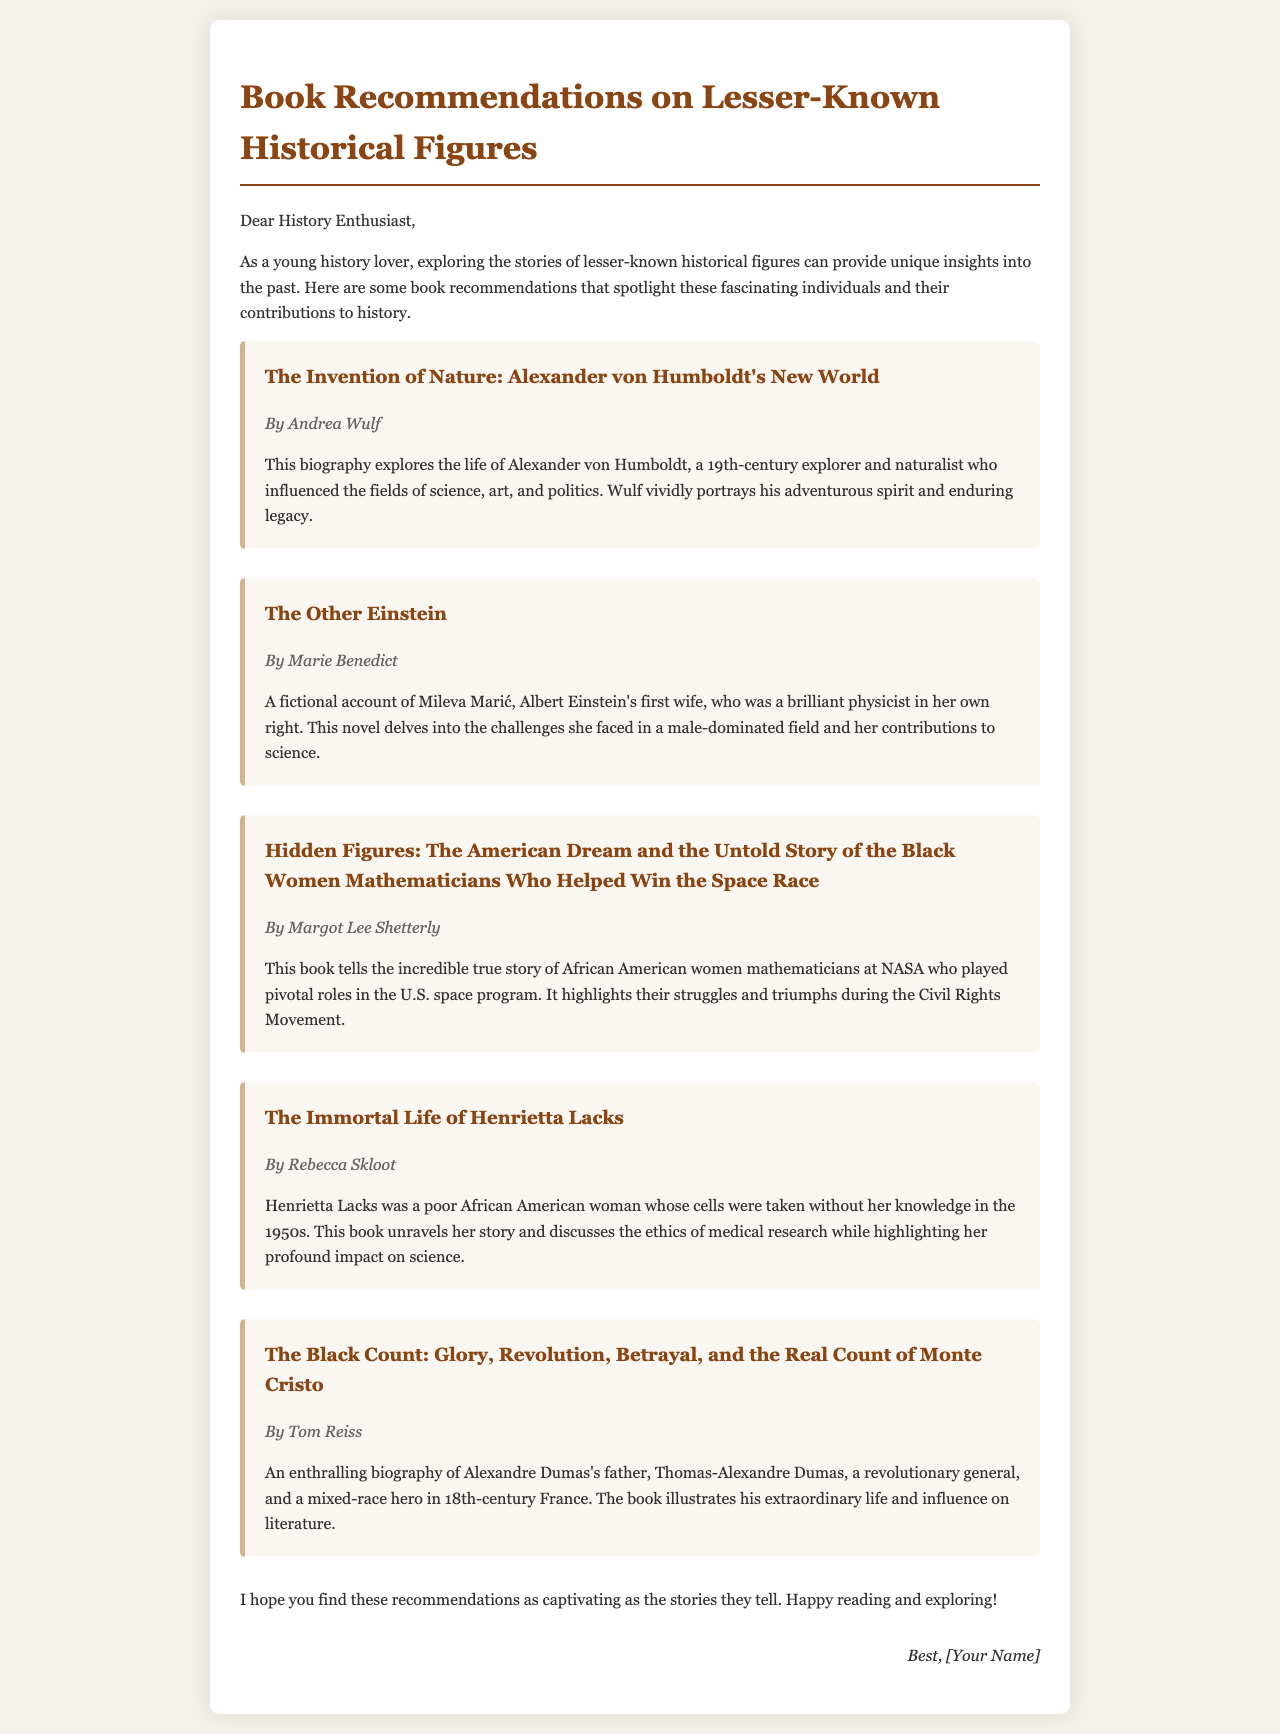What is the title of the book about Alexander von Humboldt? The title is found in the list of recommended books, highlighting the biography of the explorer and naturalist.
Answer: The Invention of Nature: Alexander von Humboldt's New World Who is the author of "The Other Einstein"? The author’s name is given alongside the book title in the recommendations, specifically for this fictional account.
Answer: Marie Benedict What significant contribution do the women in "Hidden Figures" make? The document states that the book tells the story of women mathematicians who helped in a specific historical event, indicating their roles.
Answer: The U.S. space program What infamous medical ethics issue does "The Immortal Life of Henrietta Lacks" address? The document highlights that the book discusses cells taken without knowledge, pointing to ethical concerns in medical research.
Answer: Ethics of medical research What is a common profession among the historical figures mentioned in the books? The professions can be inferred from the descriptions of the individuals, indicating their varied backgrounds and fields of influence.
Answer: Mathematicians/Scientists 